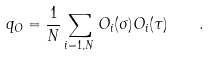<formula> <loc_0><loc_0><loc_500><loc_500>q _ { O } = \frac { 1 } { N } \sum _ { i = 1 , N } O _ { i } ( \sigma ) O _ { i } ( \tau ) \quad .</formula> 